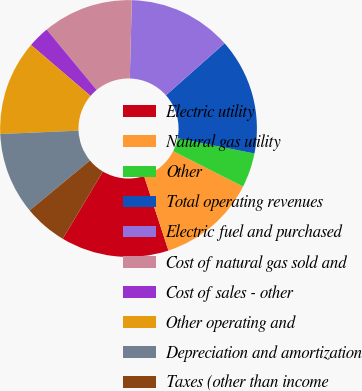Convert chart. <chart><loc_0><loc_0><loc_500><loc_500><pie_chart><fcel>Electric utility<fcel>Natural gas utility<fcel>Other<fcel>Total operating revenues<fcel>Electric fuel and purchased<fcel>Cost of natural gas sold and<fcel>Cost of sales - other<fcel>Other operating and<fcel>Depreciation and amortization<fcel>Taxes (other than income<nl><fcel>13.59%<fcel>12.5%<fcel>4.35%<fcel>14.67%<fcel>13.04%<fcel>11.41%<fcel>2.72%<fcel>11.96%<fcel>10.33%<fcel>5.43%<nl></chart> 